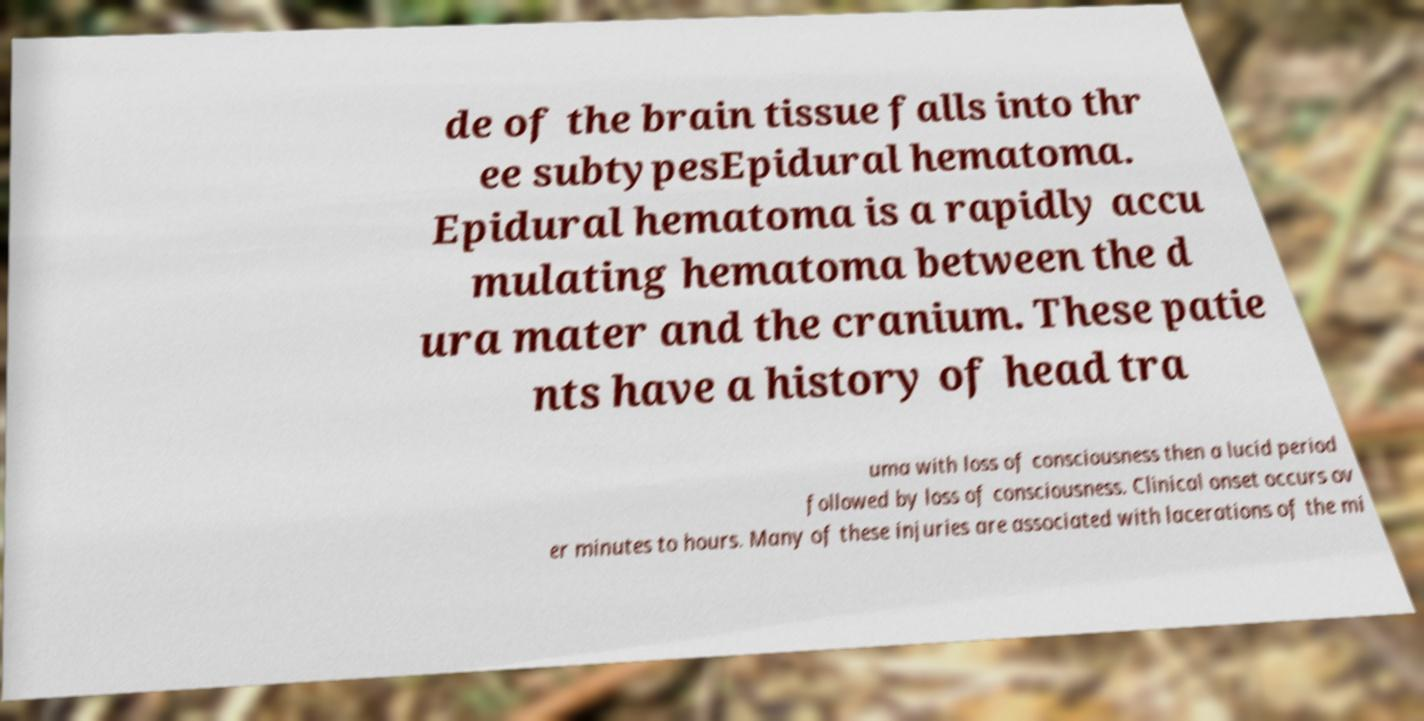There's text embedded in this image that I need extracted. Can you transcribe it verbatim? de of the brain tissue falls into thr ee subtypesEpidural hematoma. Epidural hematoma is a rapidly accu mulating hematoma between the d ura mater and the cranium. These patie nts have a history of head tra uma with loss of consciousness then a lucid period followed by loss of consciousness. Clinical onset occurs ov er minutes to hours. Many of these injuries are associated with lacerations of the mi 